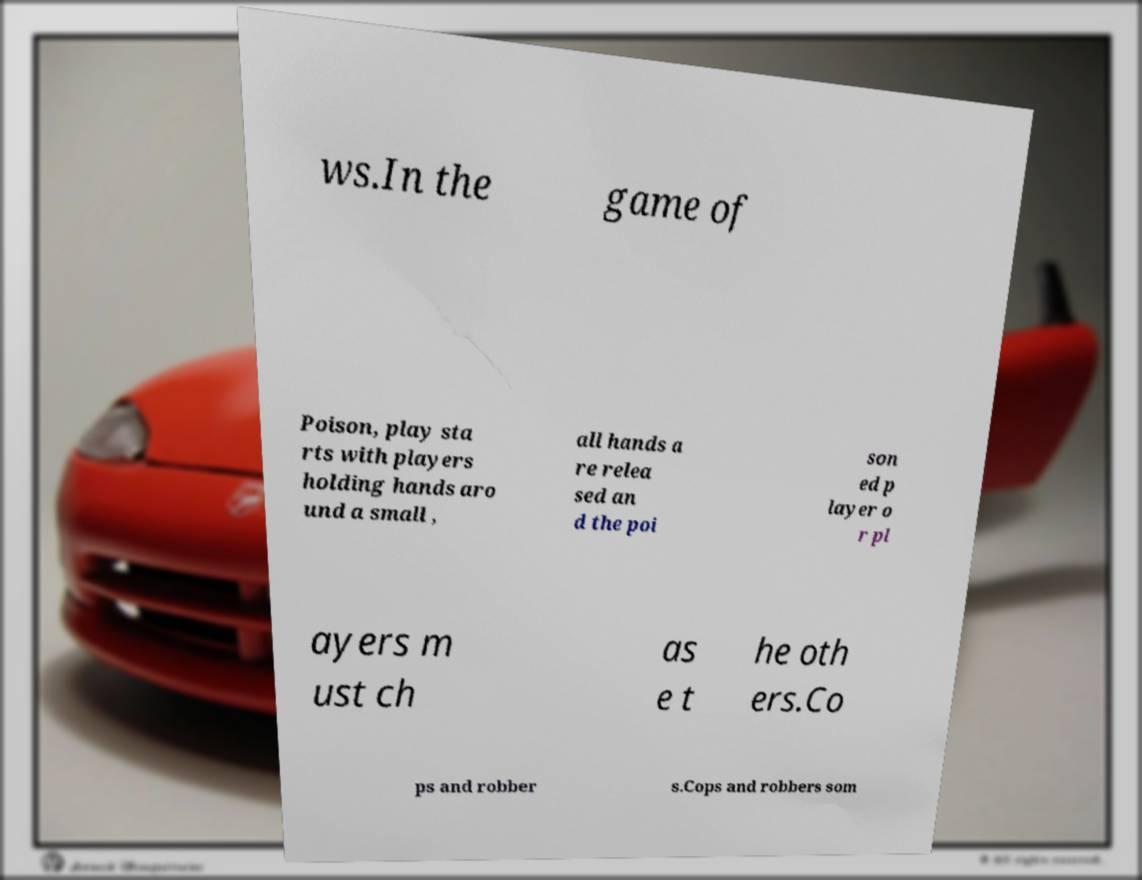Can you accurately transcribe the text from the provided image for me? ws.In the game of Poison, play sta rts with players holding hands aro und a small , all hands a re relea sed an d the poi son ed p layer o r pl ayers m ust ch as e t he oth ers.Co ps and robber s.Cops and robbers som 